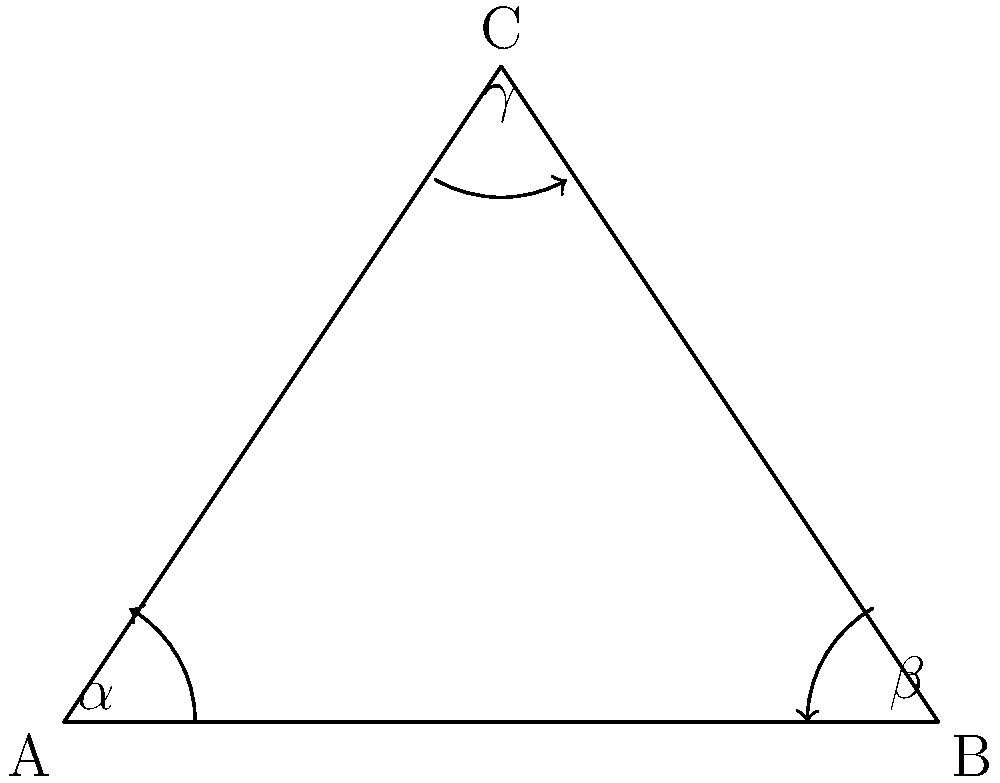In a hyperbolic triangle ABC, the angles are $\alpha$, $\beta$, and $\gamma$. If the sum of these angles is 150°, how much less is this sum compared to the sum of angles in a Euclidean triangle? To solve this problem, let's follow these steps:

1) First, recall that in Euclidean geometry, the sum of angles in a triangle is always 180°.

2) In hyperbolic geometry, however, the sum of angles in a triangle is always less than 180°. This is one of the key differences between Euclidean and hyperbolic geometry.

3) In this problem, we're given that the sum of angles in the hyperbolic triangle is 150°.

   $\alpha + \beta + \gamma = 150°$

4) To find how much less this sum is compared to a Euclidean triangle, we need to subtract:

   $180° - 150° = 30°$

5) This result shows that the sum of angles in this hyperbolic triangle is 30° less than what it would be in a Euclidean triangle.

This difference is what makes hyperbolic geometry so intriguing. It challenges our usual understanding of triangles and space, much like how an underdog challenges the established order. In the world of geometry, hyperbolic triangles are the underdogs, defying the rules we're accustomed to in Euclidean geometry.
Answer: 30° 